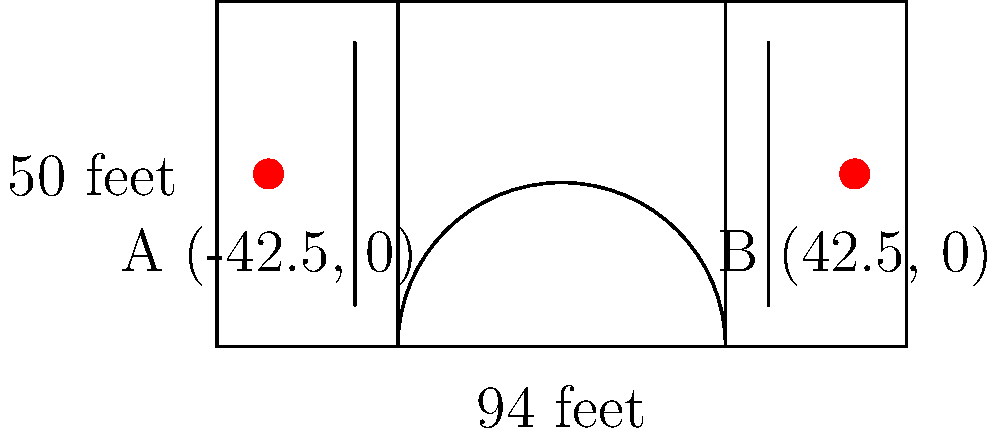As a loyal Chicago Bulls fan, you know the importance of court dimensions. In a regulation NBA basketball court, the two hoops are located at points A(-42.5, 0) and B(42.5, 0) in feet. Using the distance formula, calculate the distance between these two hoops. Round your answer to the nearest tenth of a foot. Let's approach this step-by-step:

1) The distance formula is derived from the Pythagorean theorem and is given by:
   $$d = \sqrt{(x_2 - x_1)^2 + (y_2 - y_1)^2}$$

2) We have two points:
   A(-42.5, 0) and B(42.5, 0)
   So, $(x_1, y_1) = (-42.5, 0)$ and $(x_2, y_2) = (42.5, 0)$

3) Let's substitute these into the formula:
   $$d = \sqrt{(42.5 - (-42.5))^2 + (0 - 0)^2}$$

4) Simplify inside the parentheses:
   $$d = \sqrt{(85)^2 + 0^2}$$

5) Calculate the square:
   $$d = \sqrt{7225 + 0}$$

6) Simplify:
   $$d = \sqrt{7225} = 85$$

7) The question asks to round to the nearest tenth, but 85 is already a whole number.

Therefore, the distance between the two hoops is 85.0 feet.

Fun fact for Bulls fans: This distance is the same in every NBA arena, including the United Center where the legendary Chicago Bulls play!
Answer: 85.0 feet 